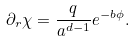<formula> <loc_0><loc_0><loc_500><loc_500>\partial _ { r } \chi = \frac { q } { a ^ { d - 1 } } e ^ { - b \phi } .</formula> 